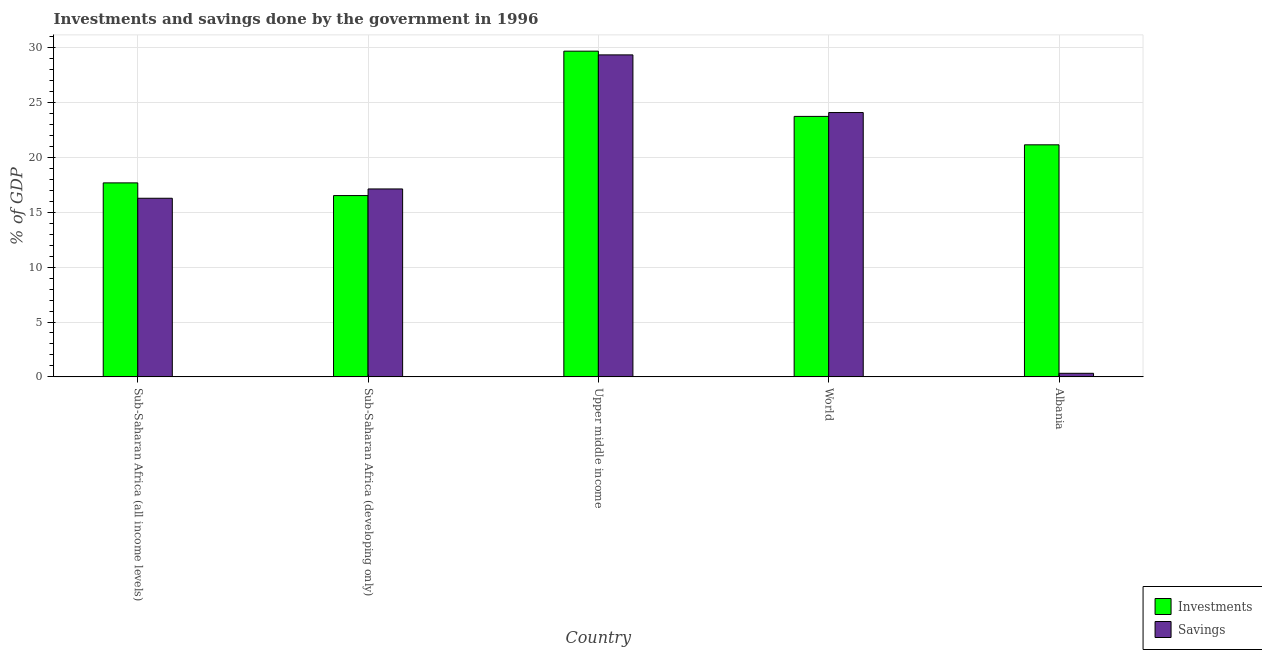Are the number of bars on each tick of the X-axis equal?
Provide a succinct answer. Yes. How many bars are there on the 3rd tick from the right?
Your answer should be very brief. 2. What is the label of the 3rd group of bars from the left?
Provide a succinct answer. Upper middle income. In how many cases, is the number of bars for a given country not equal to the number of legend labels?
Give a very brief answer. 0. What is the investments of government in Sub-Saharan Africa (all income levels)?
Give a very brief answer. 17.68. Across all countries, what is the maximum savings of government?
Your answer should be compact. 29.35. Across all countries, what is the minimum investments of government?
Offer a very short reply. 16.53. In which country was the savings of government maximum?
Provide a succinct answer. Upper middle income. In which country was the savings of government minimum?
Provide a succinct answer. Albania. What is the total investments of government in the graph?
Provide a short and direct response. 108.8. What is the difference between the savings of government in Albania and that in Upper middle income?
Your response must be concise. -29.03. What is the difference between the investments of government in Upper middle income and the savings of government in Albania?
Your answer should be compact. 29.37. What is the average savings of government per country?
Ensure brevity in your answer.  17.44. What is the difference between the savings of government and investments of government in Sub-Saharan Africa (developing only)?
Ensure brevity in your answer.  0.6. What is the ratio of the investments of government in Albania to that in Upper middle income?
Offer a terse response. 0.71. Is the investments of government in Sub-Saharan Africa (developing only) less than that in Upper middle income?
Give a very brief answer. Yes. What is the difference between the highest and the second highest savings of government?
Your response must be concise. 5.26. What is the difference between the highest and the lowest savings of government?
Provide a short and direct response. 29.03. What does the 1st bar from the left in Sub-Saharan Africa (developing only) represents?
Ensure brevity in your answer.  Investments. What does the 1st bar from the right in Sub-Saharan Africa (all income levels) represents?
Ensure brevity in your answer.  Savings. How many bars are there?
Make the answer very short. 10. How many countries are there in the graph?
Provide a succinct answer. 5. What is the difference between two consecutive major ticks on the Y-axis?
Give a very brief answer. 5. Are the values on the major ticks of Y-axis written in scientific E-notation?
Your answer should be very brief. No. Does the graph contain grids?
Offer a terse response. Yes. How many legend labels are there?
Provide a succinct answer. 2. What is the title of the graph?
Make the answer very short. Investments and savings done by the government in 1996. Does "Time to import" appear as one of the legend labels in the graph?
Provide a succinct answer. No. What is the label or title of the Y-axis?
Offer a terse response. % of GDP. What is the % of GDP in Investments in Sub-Saharan Africa (all income levels)?
Keep it short and to the point. 17.68. What is the % of GDP of Savings in Sub-Saharan Africa (all income levels)?
Give a very brief answer. 16.28. What is the % of GDP in Investments in Sub-Saharan Africa (developing only)?
Offer a terse response. 16.53. What is the % of GDP in Savings in Sub-Saharan Africa (developing only)?
Keep it short and to the point. 17.13. What is the % of GDP in Investments in Upper middle income?
Your response must be concise. 29.69. What is the % of GDP of Savings in Upper middle income?
Provide a succinct answer. 29.35. What is the % of GDP in Investments in World?
Provide a short and direct response. 23.74. What is the % of GDP in Savings in World?
Your answer should be compact. 24.1. What is the % of GDP of Investments in Albania?
Provide a short and direct response. 21.15. What is the % of GDP of Savings in Albania?
Your answer should be compact. 0.33. Across all countries, what is the maximum % of GDP in Investments?
Offer a terse response. 29.69. Across all countries, what is the maximum % of GDP in Savings?
Provide a succinct answer. 29.35. Across all countries, what is the minimum % of GDP in Investments?
Provide a short and direct response. 16.53. Across all countries, what is the minimum % of GDP in Savings?
Offer a terse response. 0.33. What is the total % of GDP of Investments in the graph?
Offer a very short reply. 108.8. What is the total % of GDP of Savings in the graph?
Provide a succinct answer. 87.19. What is the difference between the % of GDP of Investments in Sub-Saharan Africa (all income levels) and that in Sub-Saharan Africa (developing only)?
Make the answer very short. 1.16. What is the difference between the % of GDP of Savings in Sub-Saharan Africa (all income levels) and that in Sub-Saharan Africa (developing only)?
Your response must be concise. -0.85. What is the difference between the % of GDP of Investments in Sub-Saharan Africa (all income levels) and that in Upper middle income?
Provide a succinct answer. -12.01. What is the difference between the % of GDP of Savings in Sub-Saharan Africa (all income levels) and that in Upper middle income?
Give a very brief answer. -13.07. What is the difference between the % of GDP of Investments in Sub-Saharan Africa (all income levels) and that in World?
Your answer should be compact. -6.06. What is the difference between the % of GDP in Savings in Sub-Saharan Africa (all income levels) and that in World?
Your answer should be compact. -7.81. What is the difference between the % of GDP in Investments in Sub-Saharan Africa (all income levels) and that in Albania?
Offer a terse response. -3.47. What is the difference between the % of GDP of Savings in Sub-Saharan Africa (all income levels) and that in Albania?
Provide a succinct answer. 15.96. What is the difference between the % of GDP in Investments in Sub-Saharan Africa (developing only) and that in Upper middle income?
Offer a terse response. -13.16. What is the difference between the % of GDP in Savings in Sub-Saharan Africa (developing only) and that in Upper middle income?
Offer a very short reply. -12.22. What is the difference between the % of GDP of Investments in Sub-Saharan Africa (developing only) and that in World?
Ensure brevity in your answer.  -7.22. What is the difference between the % of GDP in Savings in Sub-Saharan Africa (developing only) and that in World?
Ensure brevity in your answer.  -6.97. What is the difference between the % of GDP of Investments in Sub-Saharan Africa (developing only) and that in Albania?
Your answer should be very brief. -4.63. What is the difference between the % of GDP of Savings in Sub-Saharan Africa (developing only) and that in Albania?
Make the answer very short. 16.81. What is the difference between the % of GDP of Investments in Upper middle income and that in World?
Your response must be concise. 5.95. What is the difference between the % of GDP of Savings in Upper middle income and that in World?
Your answer should be compact. 5.26. What is the difference between the % of GDP of Investments in Upper middle income and that in Albania?
Your answer should be compact. 8.54. What is the difference between the % of GDP in Savings in Upper middle income and that in Albania?
Offer a terse response. 29.03. What is the difference between the % of GDP of Investments in World and that in Albania?
Make the answer very short. 2.59. What is the difference between the % of GDP in Savings in World and that in Albania?
Make the answer very short. 23.77. What is the difference between the % of GDP in Investments in Sub-Saharan Africa (all income levels) and the % of GDP in Savings in Sub-Saharan Africa (developing only)?
Ensure brevity in your answer.  0.55. What is the difference between the % of GDP in Investments in Sub-Saharan Africa (all income levels) and the % of GDP in Savings in Upper middle income?
Your answer should be compact. -11.67. What is the difference between the % of GDP in Investments in Sub-Saharan Africa (all income levels) and the % of GDP in Savings in World?
Make the answer very short. -6.41. What is the difference between the % of GDP of Investments in Sub-Saharan Africa (all income levels) and the % of GDP of Savings in Albania?
Your answer should be very brief. 17.36. What is the difference between the % of GDP in Investments in Sub-Saharan Africa (developing only) and the % of GDP in Savings in Upper middle income?
Provide a succinct answer. -12.82. What is the difference between the % of GDP of Investments in Sub-Saharan Africa (developing only) and the % of GDP of Savings in World?
Your response must be concise. -7.57. What is the difference between the % of GDP of Investments in Sub-Saharan Africa (developing only) and the % of GDP of Savings in Albania?
Provide a succinct answer. 16.2. What is the difference between the % of GDP in Investments in Upper middle income and the % of GDP in Savings in World?
Your answer should be very brief. 5.6. What is the difference between the % of GDP in Investments in Upper middle income and the % of GDP in Savings in Albania?
Offer a very short reply. 29.37. What is the difference between the % of GDP in Investments in World and the % of GDP in Savings in Albania?
Provide a succinct answer. 23.42. What is the average % of GDP of Investments per country?
Offer a terse response. 21.76. What is the average % of GDP of Savings per country?
Provide a short and direct response. 17.44. What is the difference between the % of GDP in Investments and % of GDP in Savings in Sub-Saharan Africa (all income levels)?
Ensure brevity in your answer.  1.4. What is the difference between the % of GDP in Investments and % of GDP in Savings in Sub-Saharan Africa (developing only)?
Offer a terse response. -0.6. What is the difference between the % of GDP in Investments and % of GDP in Savings in Upper middle income?
Make the answer very short. 0.34. What is the difference between the % of GDP in Investments and % of GDP in Savings in World?
Offer a very short reply. -0.35. What is the difference between the % of GDP in Investments and % of GDP in Savings in Albania?
Offer a very short reply. 20.83. What is the ratio of the % of GDP in Investments in Sub-Saharan Africa (all income levels) to that in Sub-Saharan Africa (developing only)?
Your answer should be compact. 1.07. What is the ratio of the % of GDP in Savings in Sub-Saharan Africa (all income levels) to that in Sub-Saharan Africa (developing only)?
Provide a short and direct response. 0.95. What is the ratio of the % of GDP of Investments in Sub-Saharan Africa (all income levels) to that in Upper middle income?
Give a very brief answer. 0.6. What is the ratio of the % of GDP in Savings in Sub-Saharan Africa (all income levels) to that in Upper middle income?
Offer a terse response. 0.55. What is the ratio of the % of GDP of Investments in Sub-Saharan Africa (all income levels) to that in World?
Offer a terse response. 0.74. What is the ratio of the % of GDP in Savings in Sub-Saharan Africa (all income levels) to that in World?
Keep it short and to the point. 0.68. What is the ratio of the % of GDP of Investments in Sub-Saharan Africa (all income levels) to that in Albania?
Ensure brevity in your answer.  0.84. What is the ratio of the % of GDP in Savings in Sub-Saharan Africa (all income levels) to that in Albania?
Give a very brief answer. 50. What is the ratio of the % of GDP of Investments in Sub-Saharan Africa (developing only) to that in Upper middle income?
Your response must be concise. 0.56. What is the ratio of the % of GDP in Savings in Sub-Saharan Africa (developing only) to that in Upper middle income?
Your response must be concise. 0.58. What is the ratio of the % of GDP of Investments in Sub-Saharan Africa (developing only) to that in World?
Your answer should be very brief. 0.7. What is the ratio of the % of GDP of Savings in Sub-Saharan Africa (developing only) to that in World?
Offer a very short reply. 0.71. What is the ratio of the % of GDP in Investments in Sub-Saharan Africa (developing only) to that in Albania?
Ensure brevity in your answer.  0.78. What is the ratio of the % of GDP in Savings in Sub-Saharan Africa (developing only) to that in Albania?
Keep it short and to the point. 52.6. What is the ratio of the % of GDP of Investments in Upper middle income to that in World?
Your answer should be compact. 1.25. What is the ratio of the % of GDP of Savings in Upper middle income to that in World?
Your answer should be compact. 1.22. What is the ratio of the % of GDP of Investments in Upper middle income to that in Albania?
Provide a short and direct response. 1.4. What is the ratio of the % of GDP of Savings in Upper middle income to that in Albania?
Give a very brief answer. 90.13. What is the ratio of the % of GDP of Investments in World to that in Albania?
Your answer should be very brief. 1.12. What is the ratio of the % of GDP of Savings in World to that in Albania?
Provide a short and direct response. 73.99. What is the difference between the highest and the second highest % of GDP in Investments?
Keep it short and to the point. 5.95. What is the difference between the highest and the second highest % of GDP of Savings?
Make the answer very short. 5.26. What is the difference between the highest and the lowest % of GDP in Investments?
Your answer should be very brief. 13.16. What is the difference between the highest and the lowest % of GDP in Savings?
Provide a succinct answer. 29.03. 